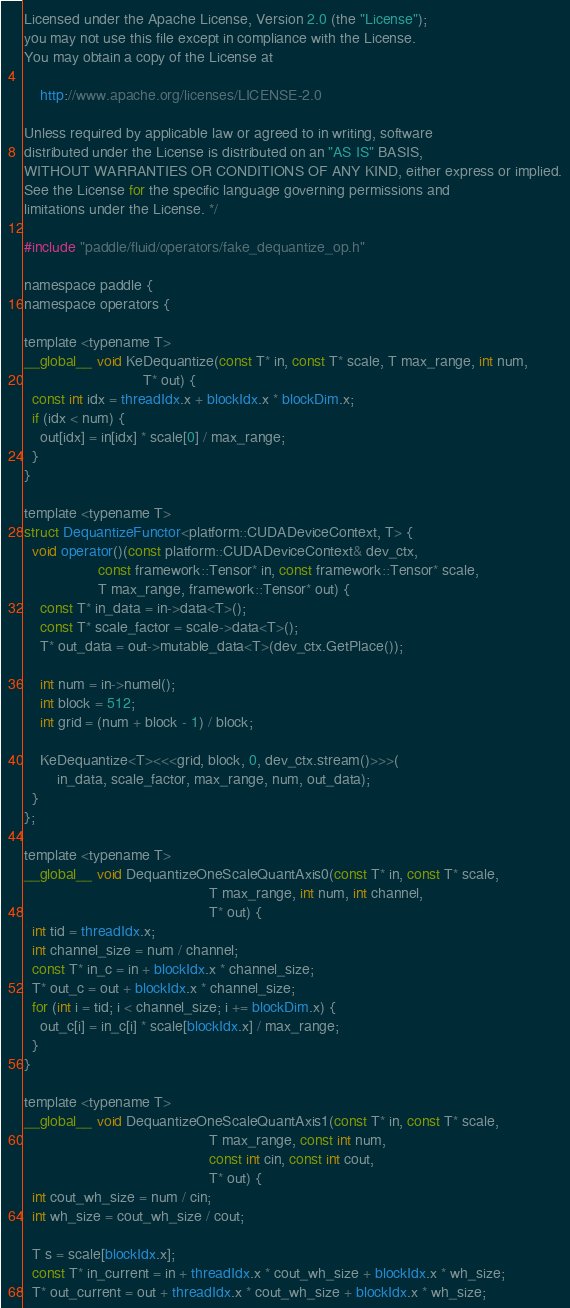Convert code to text. <code><loc_0><loc_0><loc_500><loc_500><_Cuda_>
Licensed under the Apache License, Version 2.0 (the "License");
you may not use this file except in compliance with the License.
You may obtain a copy of the License at

    http://www.apache.org/licenses/LICENSE-2.0

Unless required by applicable law or agreed to in writing, software
distributed under the License is distributed on an "AS IS" BASIS,
WITHOUT WARRANTIES OR CONDITIONS OF ANY KIND, either express or implied.
See the License for the specific language governing permissions and
limitations under the License. */

#include "paddle/fluid/operators/fake_dequantize_op.h"

namespace paddle {
namespace operators {

template <typename T>
__global__ void KeDequantize(const T* in, const T* scale, T max_range, int num,
                             T* out) {
  const int idx = threadIdx.x + blockIdx.x * blockDim.x;
  if (idx < num) {
    out[idx] = in[idx] * scale[0] / max_range;
  }
}

template <typename T>
struct DequantizeFunctor<platform::CUDADeviceContext, T> {
  void operator()(const platform::CUDADeviceContext& dev_ctx,
                  const framework::Tensor* in, const framework::Tensor* scale,
                  T max_range, framework::Tensor* out) {
    const T* in_data = in->data<T>();
    const T* scale_factor = scale->data<T>();
    T* out_data = out->mutable_data<T>(dev_ctx.GetPlace());

    int num = in->numel();
    int block = 512;
    int grid = (num + block - 1) / block;

    KeDequantize<T><<<grid, block, 0, dev_ctx.stream()>>>(
        in_data, scale_factor, max_range, num, out_data);
  }
};

template <typename T>
__global__ void DequantizeOneScaleQuantAxis0(const T* in, const T* scale,
                                             T max_range, int num, int channel,
                                             T* out) {
  int tid = threadIdx.x;
  int channel_size = num / channel;
  const T* in_c = in + blockIdx.x * channel_size;
  T* out_c = out + blockIdx.x * channel_size;
  for (int i = tid; i < channel_size; i += blockDim.x) {
    out_c[i] = in_c[i] * scale[blockIdx.x] / max_range;
  }
}

template <typename T>
__global__ void DequantizeOneScaleQuantAxis1(const T* in, const T* scale,
                                             T max_range, const int num,
                                             const int cin, const int cout,
                                             T* out) {
  int cout_wh_size = num / cin;
  int wh_size = cout_wh_size / cout;

  T s = scale[blockIdx.x];
  const T* in_current = in + threadIdx.x * cout_wh_size + blockIdx.x * wh_size;
  T* out_current = out + threadIdx.x * cout_wh_size + blockIdx.x * wh_size;
</code> 